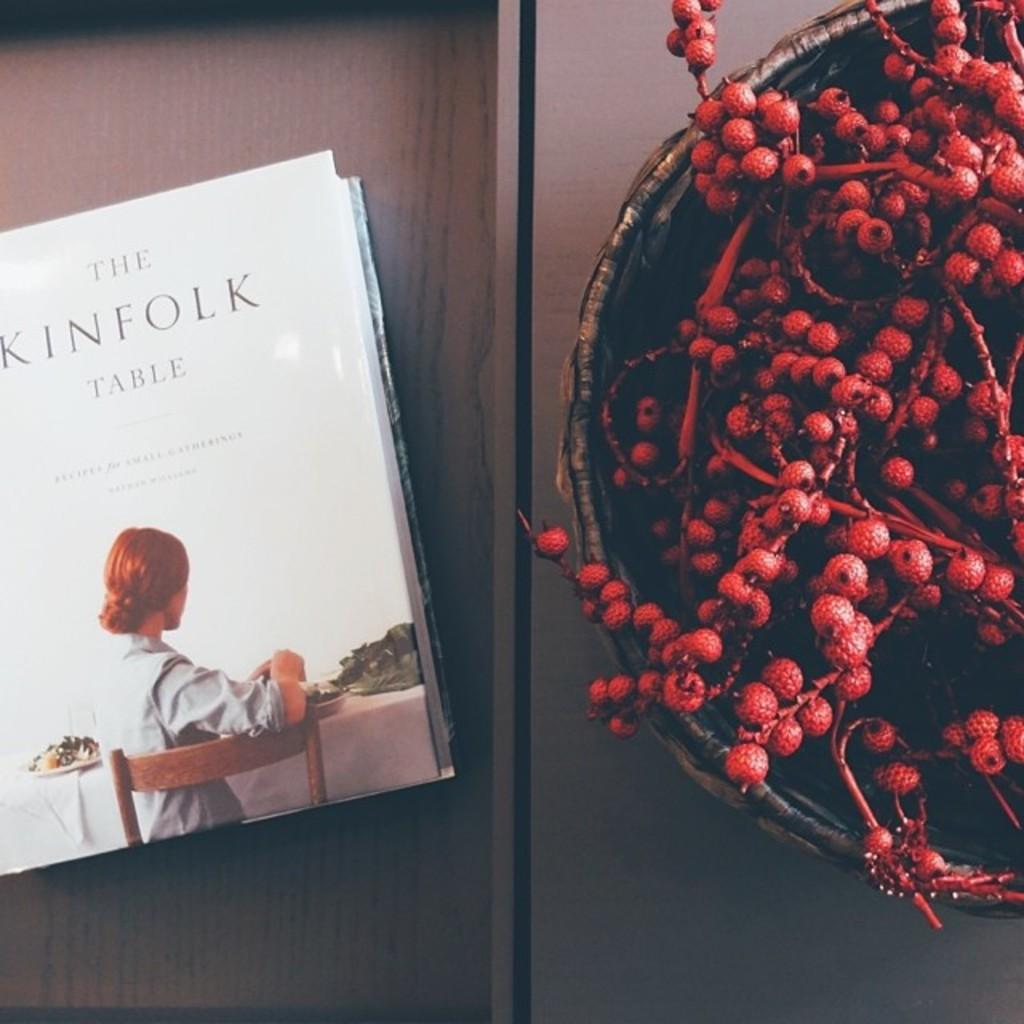Provide a one-sentence caption for the provided image. Book called the kinfolk table with a bowl of berries next to it. 